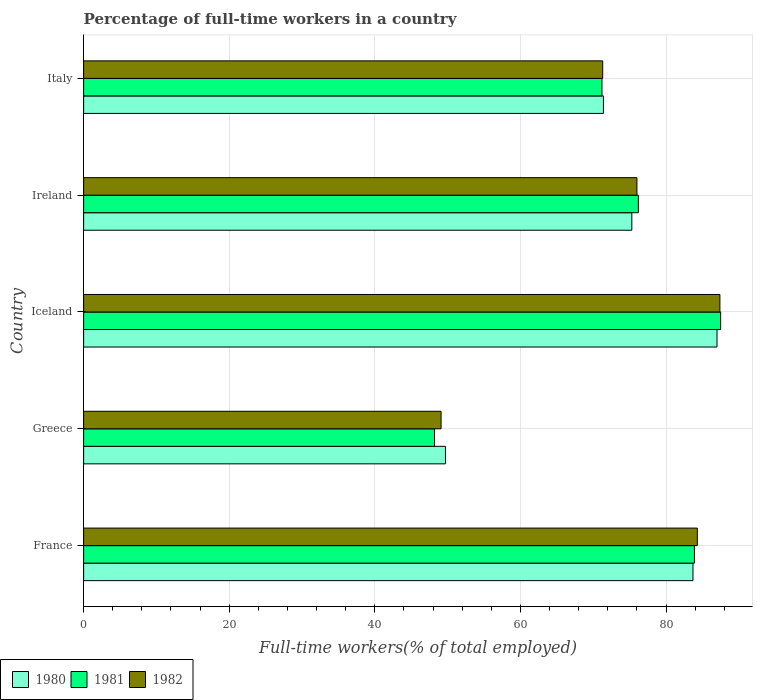How many different coloured bars are there?
Provide a succinct answer. 3. How many groups of bars are there?
Give a very brief answer. 5. Are the number of bars on each tick of the Y-axis equal?
Offer a terse response. Yes. How many bars are there on the 3rd tick from the top?
Your answer should be compact. 3. How many bars are there on the 3rd tick from the bottom?
Offer a very short reply. 3. What is the label of the 4th group of bars from the top?
Provide a short and direct response. Greece. In how many cases, is the number of bars for a given country not equal to the number of legend labels?
Your answer should be very brief. 0. What is the percentage of full-time workers in 1981 in Iceland?
Your answer should be compact. 87.5. Across all countries, what is the maximum percentage of full-time workers in 1980?
Provide a succinct answer. 87. Across all countries, what is the minimum percentage of full-time workers in 1980?
Make the answer very short. 49.7. In which country was the percentage of full-time workers in 1980 maximum?
Provide a succinct answer. Iceland. In which country was the percentage of full-time workers in 1981 minimum?
Provide a succinct answer. Greece. What is the total percentage of full-time workers in 1980 in the graph?
Your answer should be very brief. 367.1. What is the difference between the percentage of full-time workers in 1980 in France and that in Ireland?
Keep it short and to the point. 8.4. What is the difference between the percentage of full-time workers in 1980 in Italy and the percentage of full-time workers in 1981 in Iceland?
Make the answer very short. -16.1. What is the average percentage of full-time workers in 1980 per country?
Offer a very short reply. 73.42. What is the difference between the percentage of full-time workers in 1981 and percentage of full-time workers in 1980 in Ireland?
Ensure brevity in your answer.  0.9. What is the ratio of the percentage of full-time workers in 1982 in Greece to that in Italy?
Give a very brief answer. 0.69. What is the difference between the highest and the second highest percentage of full-time workers in 1982?
Provide a succinct answer. 3.1. What is the difference between the highest and the lowest percentage of full-time workers in 1981?
Your response must be concise. 39.3. In how many countries, is the percentage of full-time workers in 1981 greater than the average percentage of full-time workers in 1981 taken over all countries?
Make the answer very short. 3. Is the sum of the percentage of full-time workers in 1982 in Ireland and Italy greater than the maximum percentage of full-time workers in 1981 across all countries?
Offer a very short reply. Yes. What does the 3rd bar from the bottom in Greece represents?
Ensure brevity in your answer.  1982. Is it the case that in every country, the sum of the percentage of full-time workers in 1981 and percentage of full-time workers in 1982 is greater than the percentage of full-time workers in 1980?
Your answer should be very brief. Yes. Are all the bars in the graph horizontal?
Ensure brevity in your answer.  Yes. How many countries are there in the graph?
Your answer should be very brief. 5. What is the difference between two consecutive major ticks on the X-axis?
Keep it short and to the point. 20. Does the graph contain any zero values?
Provide a succinct answer. No. Does the graph contain grids?
Offer a terse response. Yes. How many legend labels are there?
Make the answer very short. 3. How are the legend labels stacked?
Your answer should be compact. Horizontal. What is the title of the graph?
Your answer should be compact. Percentage of full-time workers in a country. Does "1962" appear as one of the legend labels in the graph?
Offer a very short reply. No. What is the label or title of the X-axis?
Ensure brevity in your answer.  Full-time workers(% of total employed). What is the Full-time workers(% of total employed) of 1980 in France?
Provide a short and direct response. 83.7. What is the Full-time workers(% of total employed) of 1981 in France?
Ensure brevity in your answer.  83.9. What is the Full-time workers(% of total employed) in 1982 in France?
Ensure brevity in your answer.  84.3. What is the Full-time workers(% of total employed) of 1980 in Greece?
Keep it short and to the point. 49.7. What is the Full-time workers(% of total employed) of 1981 in Greece?
Ensure brevity in your answer.  48.2. What is the Full-time workers(% of total employed) in 1982 in Greece?
Give a very brief answer. 49.1. What is the Full-time workers(% of total employed) of 1981 in Iceland?
Your answer should be compact. 87.5. What is the Full-time workers(% of total employed) of 1982 in Iceland?
Your answer should be compact. 87.4. What is the Full-time workers(% of total employed) of 1980 in Ireland?
Make the answer very short. 75.3. What is the Full-time workers(% of total employed) in 1981 in Ireland?
Your answer should be very brief. 76.2. What is the Full-time workers(% of total employed) in 1982 in Ireland?
Offer a very short reply. 76. What is the Full-time workers(% of total employed) of 1980 in Italy?
Offer a very short reply. 71.4. What is the Full-time workers(% of total employed) of 1981 in Italy?
Provide a short and direct response. 71.2. What is the Full-time workers(% of total employed) in 1982 in Italy?
Make the answer very short. 71.3. Across all countries, what is the maximum Full-time workers(% of total employed) of 1980?
Your response must be concise. 87. Across all countries, what is the maximum Full-time workers(% of total employed) of 1981?
Your response must be concise. 87.5. Across all countries, what is the maximum Full-time workers(% of total employed) of 1982?
Your answer should be compact. 87.4. Across all countries, what is the minimum Full-time workers(% of total employed) of 1980?
Keep it short and to the point. 49.7. Across all countries, what is the minimum Full-time workers(% of total employed) in 1981?
Provide a succinct answer. 48.2. Across all countries, what is the minimum Full-time workers(% of total employed) in 1982?
Your answer should be very brief. 49.1. What is the total Full-time workers(% of total employed) in 1980 in the graph?
Your response must be concise. 367.1. What is the total Full-time workers(% of total employed) in 1981 in the graph?
Your answer should be very brief. 367. What is the total Full-time workers(% of total employed) of 1982 in the graph?
Your response must be concise. 368.1. What is the difference between the Full-time workers(% of total employed) of 1980 in France and that in Greece?
Ensure brevity in your answer.  34. What is the difference between the Full-time workers(% of total employed) in 1981 in France and that in Greece?
Offer a very short reply. 35.7. What is the difference between the Full-time workers(% of total employed) of 1982 in France and that in Greece?
Provide a short and direct response. 35.2. What is the difference between the Full-time workers(% of total employed) of 1980 in France and that in Iceland?
Keep it short and to the point. -3.3. What is the difference between the Full-time workers(% of total employed) in 1982 in France and that in Iceland?
Give a very brief answer. -3.1. What is the difference between the Full-time workers(% of total employed) of 1981 in France and that in Ireland?
Your response must be concise. 7.7. What is the difference between the Full-time workers(% of total employed) of 1980 in France and that in Italy?
Provide a succinct answer. 12.3. What is the difference between the Full-time workers(% of total employed) in 1980 in Greece and that in Iceland?
Give a very brief answer. -37.3. What is the difference between the Full-time workers(% of total employed) in 1981 in Greece and that in Iceland?
Give a very brief answer. -39.3. What is the difference between the Full-time workers(% of total employed) in 1982 in Greece and that in Iceland?
Offer a terse response. -38.3. What is the difference between the Full-time workers(% of total employed) in 1980 in Greece and that in Ireland?
Provide a succinct answer. -25.6. What is the difference between the Full-time workers(% of total employed) of 1982 in Greece and that in Ireland?
Make the answer very short. -26.9. What is the difference between the Full-time workers(% of total employed) of 1980 in Greece and that in Italy?
Provide a short and direct response. -21.7. What is the difference between the Full-time workers(% of total employed) of 1981 in Greece and that in Italy?
Keep it short and to the point. -23. What is the difference between the Full-time workers(% of total employed) of 1982 in Greece and that in Italy?
Provide a short and direct response. -22.2. What is the difference between the Full-time workers(% of total employed) in 1982 in Iceland and that in Ireland?
Keep it short and to the point. 11.4. What is the difference between the Full-time workers(% of total employed) of 1982 in Iceland and that in Italy?
Offer a very short reply. 16.1. What is the difference between the Full-time workers(% of total employed) of 1980 in Ireland and that in Italy?
Ensure brevity in your answer.  3.9. What is the difference between the Full-time workers(% of total employed) of 1981 in Ireland and that in Italy?
Offer a terse response. 5. What is the difference between the Full-time workers(% of total employed) of 1980 in France and the Full-time workers(% of total employed) of 1981 in Greece?
Your answer should be very brief. 35.5. What is the difference between the Full-time workers(% of total employed) in 1980 in France and the Full-time workers(% of total employed) in 1982 in Greece?
Your answer should be very brief. 34.6. What is the difference between the Full-time workers(% of total employed) of 1981 in France and the Full-time workers(% of total employed) of 1982 in Greece?
Provide a succinct answer. 34.8. What is the difference between the Full-time workers(% of total employed) of 1981 in France and the Full-time workers(% of total employed) of 1982 in Iceland?
Give a very brief answer. -3.5. What is the difference between the Full-time workers(% of total employed) of 1980 in France and the Full-time workers(% of total employed) of 1981 in Ireland?
Ensure brevity in your answer.  7.5. What is the difference between the Full-time workers(% of total employed) of 1980 in France and the Full-time workers(% of total employed) of 1982 in Ireland?
Ensure brevity in your answer.  7.7. What is the difference between the Full-time workers(% of total employed) in 1980 in France and the Full-time workers(% of total employed) in 1981 in Italy?
Ensure brevity in your answer.  12.5. What is the difference between the Full-time workers(% of total employed) in 1981 in France and the Full-time workers(% of total employed) in 1982 in Italy?
Make the answer very short. 12.6. What is the difference between the Full-time workers(% of total employed) in 1980 in Greece and the Full-time workers(% of total employed) in 1981 in Iceland?
Make the answer very short. -37.8. What is the difference between the Full-time workers(% of total employed) in 1980 in Greece and the Full-time workers(% of total employed) in 1982 in Iceland?
Offer a terse response. -37.7. What is the difference between the Full-time workers(% of total employed) of 1981 in Greece and the Full-time workers(% of total employed) of 1982 in Iceland?
Offer a terse response. -39.2. What is the difference between the Full-time workers(% of total employed) of 1980 in Greece and the Full-time workers(% of total employed) of 1981 in Ireland?
Keep it short and to the point. -26.5. What is the difference between the Full-time workers(% of total employed) of 1980 in Greece and the Full-time workers(% of total employed) of 1982 in Ireland?
Offer a very short reply. -26.3. What is the difference between the Full-time workers(% of total employed) in 1981 in Greece and the Full-time workers(% of total employed) in 1982 in Ireland?
Provide a short and direct response. -27.8. What is the difference between the Full-time workers(% of total employed) of 1980 in Greece and the Full-time workers(% of total employed) of 1981 in Italy?
Your answer should be compact. -21.5. What is the difference between the Full-time workers(% of total employed) of 1980 in Greece and the Full-time workers(% of total employed) of 1982 in Italy?
Ensure brevity in your answer.  -21.6. What is the difference between the Full-time workers(% of total employed) of 1981 in Greece and the Full-time workers(% of total employed) of 1982 in Italy?
Offer a terse response. -23.1. What is the difference between the Full-time workers(% of total employed) of 1980 in Iceland and the Full-time workers(% of total employed) of 1981 in Ireland?
Offer a very short reply. 10.8. What is the difference between the Full-time workers(% of total employed) of 1980 in Iceland and the Full-time workers(% of total employed) of 1982 in Ireland?
Offer a terse response. 11. What is the difference between the Full-time workers(% of total employed) in 1981 in Iceland and the Full-time workers(% of total employed) in 1982 in Italy?
Make the answer very short. 16.2. What is the difference between the Full-time workers(% of total employed) in 1980 in Ireland and the Full-time workers(% of total employed) in 1981 in Italy?
Ensure brevity in your answer.  4.1. What is the difference between the Full-time workers(% of total employed) of 1981 in Ireland and the Full-time workers(% of total employed) of 1982 in Italy?
Provide a succinct answer. 4.9. What is the average Full-time workers(% of total employed) in 1980 per country?
Your answer should be very brief. 73.42. What is the average Full-time workers(% of total employed) of 1981 per country?
Give a very brief answer. 73.4. What is the average Full-time workers(% of total employed) of 1982 per country?
Keep it short and to the point. 73.62. What is the difference between the Full-time workers(% of total employed) of 1980 and Full-time workers(% of total employed) of 1981 in France?
Provide a succinct answer. -0.2. What is the difference between the Full-time workers(% of total employed) of 1980 and Full-time workers(% of total employed) of 1982 in France?
Make the answer very short. -0.6. What is the difference between the Full-time workers(% of total employed) in 1980 and Full-time workers(% of total employed) in 1981 in Greece?
Provide a short and direct response. 1.5. What is the difference between the Full-time workers(% of total employed) of 1980 and Full-time workers(% of total employed) of 1982 in Greece?
Your answer should be very brief. 0.6. What is the difference between the Full-time workers(% of total employed) in 1980 and Full-time workers(% of total employed) in 1982 in Iceland?
Ensure brevity in your answer.  -0.4. What is the difference between the Full-time workers(% of total employed) of 1980 and Full-time workers(% of total employed) of 1981 in Ireland?
Ensure brevity in your answer.  -0.9. What is the difference between the Full-time workers(% of total employed) of 1981 and Full-time workers(% of total employed) of 1982 in Ireland?
Give a very brief answer. 0.2. What is the difference between the Full-time workers(% of total employed) of 1980 and Full-time workers(% of total employed) of 1982 in Italy?
Keep it short and to the point. 0.1. What is the ratio of the Full-time workers(% of total employed) in 1980 in France to that in Greece?
Your answer should be very brief. 1.68. What is the ratio of the Full-time workers(% of total employed) of 1981 in France to that in Greece?
Give a very brief answer. 1.74. What is the ratio of the Full-time workers(% of total employed) of 1982 in France to that in Greece?
Provide a short and direct response. 1.72. What is the ratio of the Full-time workers(% of total employed) of 1980 in France to that in Iceland?
Keep it short and to the point. 0.96. What is the ratio of the Full-time workers(% of total employed) in 1981 in France to that in Iceland?
Your answer should be very brief. 0.96. What is the ratio of the Full-time workers(% of total employed) of 1982 in France to that in Iceland?
Provide a succinct answer. 0.96. What is the ratio of the Full-time workers(% of total employed) of 1980 in France to that in Ireland?
Your answer should be compact. 1.11. What is the ratio of the Full-time workers(% of total employed) in 1981 in France to that in Ireland?
Ensure brevity in your answer.  1.1. What is the ratio of the Full-time workers(% of total employed) in 1982 in France to that in Ireland?
Your answer should be compact. 1.11. What is the ratio of the Full-time workers(% of total employed) in 1980 in France to that in Italy?
Your answer should be very brief. 1.17. What is the ratio of the Full-time workers(% of total employed) in 1981 in France to that in Italy?
Your answer should be compact. 1.18. What is the ratio of the Full-time workers(% of total employed) in 1982 in France to that in Italy?
Provide a short and direct response. 1.18. What is the ratio of the Full-time workers(% of total employed) of 1980 in Greece to that in Iceland?
Make the answer very short. 0.57. What is the ratio of the Full-time workers(% of total employed) of 1981 in Greece to that in Iceland?
Your answer should be very brief. 0.55. What is the ratio of the Full-time workers(% of total employed) in 1982 in Greece to that in Iceland?
Offer a terse response. 0.56. What is the ratio of the Full-time workers(% of total employed) in 1980 in Greece to that in Ireland?
Ensure brevity in your answer.  0.66. What is the ratio of the Full-time workers(% of total employed) in 1981 in Greece to that in Ireland?
Your answer should be very brief. 0.63. What is the ratio of the Full-time workers(% of total employed) in 1982 in Greece to that in Ireland?
Your response must be concise. 0.65. What is the ratio of the Full-time workers(% of total employed) in 1980 in Greece to that in Italy?
Make the answer very short. 0.7. What is the ratio of the Full-time workers(% of total employed) of 1981 in Greece to that in Italy?
Ensure brevity in your answer.  0.68. What is the ratio of the Full-time workers(% of total employed) of 1982 in Greece to that in Italy?
Offer a terse response. 0.69. What is the ratio of the Full-time workers(% of total employed) of 1980 in Iceland to that in Ireland?
Your answer should be compact. 1.16. What is the ratio of the Full-time workers(% of total employed) of 1981 in Iceland to that in Ireland?
Make the answer very short. 1.15. What is the ratio of the Full-time workers(% of total employed) of 1982 in Iceland to that in Ireland?
Ensure brevity in your answer.  1.15. What is the ratio of the Full-time workers(% of total employed) in 1980 in Iceland to that in Italy?
Ensure brevity in your answer.  1.22. What is the ratio of the Full-time workers(% of total employed) of 1981 in Iceland to that in Italy?
Keep it short and to the point. 1.23. What is the ratio of the Full-time workers(% of total employed) of 1982 in Iceland to that in Italy?
Ensure brevity in your answer.  1.23. What is the ratio of the Full-time workers(% of total employed) of 1980 in Ireland to that in Italy?
Make the answer very short. 1.05. What is the ratio of the Full-time workers(% of total employed) in 1981 in Ireland to that in Italy?
Keep it short and to the point. 1.07. What is the ratio of the Full-time workers(% of total employed) of 1982 in Ireland to that in Italy?
Your answer should be compact. 1.07. What is the difference between the highest and the second highest Full-time workers(% of total employed) of 1981?
Your response must be concise. 3.6. What is the difference between the highest and the second highest Full-time workers(% of total employed) in 1982?
Your answer should be compact. 3.1. What is the difference between the highest and the lowest Full-time workers(% of total employed) in 1980?
Give a very brief answer. 37.3. What is the difference between the highest and the lowest Full-time workers(% of total employed) in 1981?
Ensure brevity in your answer.  39.3. What is the difference between the highest and the lowest Full-time workers(% of total employed) of 1982?
Provide a short and direct response. 38.3. 